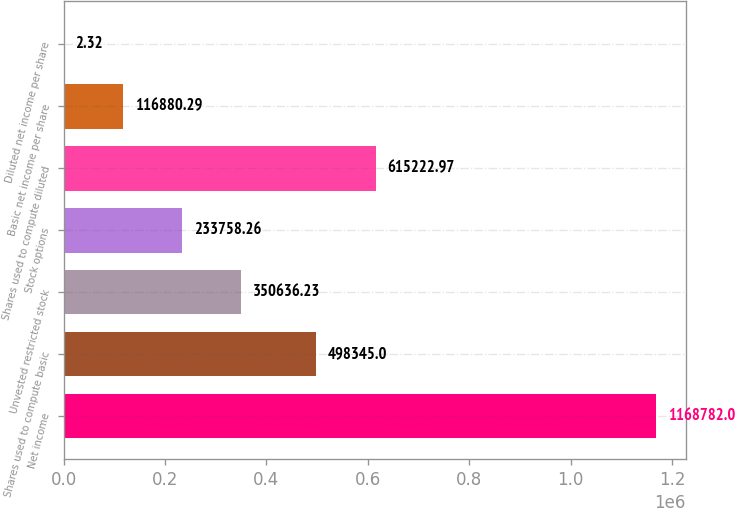<chart> <loc_0><loc_0><loc_500><loc_500><bar_chart><fcel>Net income<fcel>Shares used to compute basic<fcel>Unvested restricted stock<fcel>Stock options<fcel>Shares used to compute diluted<fcel>Basic net income per share<fcel>Diluted net income per share<nl><fcel>1.16878e+06<fcel>498345<fcel>350636<fcel>233758<fcel>615223<fcel>116880<fcel>2.32<nl></chart> 